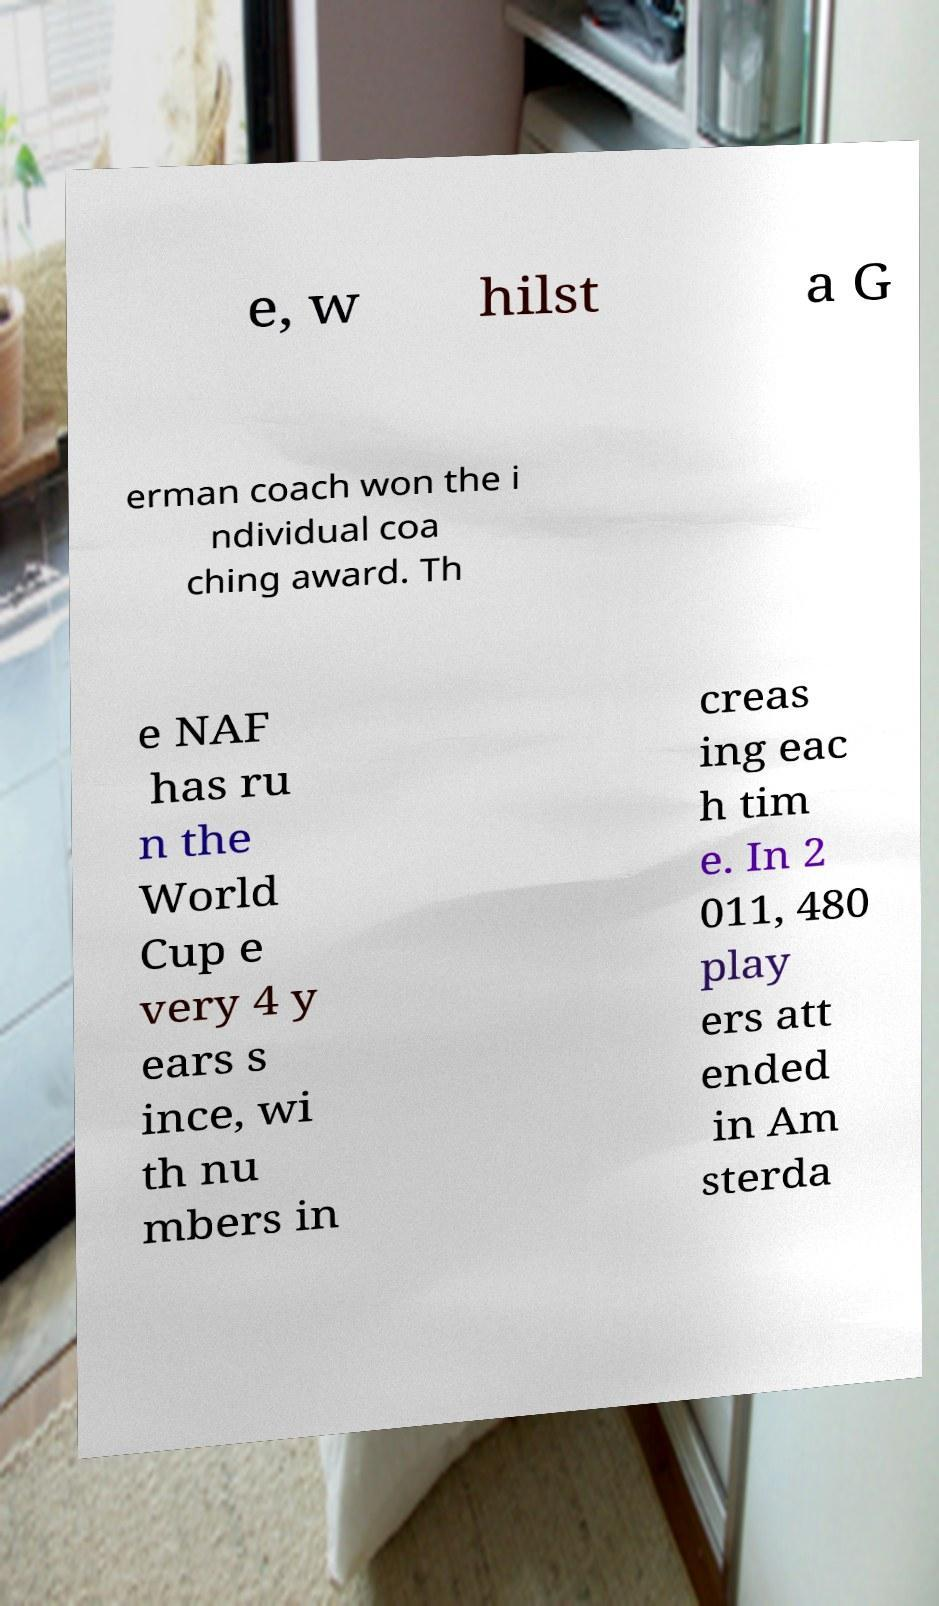Could you extract and type out the text from this image? e, w hilst a G erman coach won the i ndividual coa ching award. Th e NAF has ru n the World Cup e very 4 y ears s ince, wi th nu mbers in creas ing eac h tim e. In 2 011, 480 play ers att ended in Am sterda 